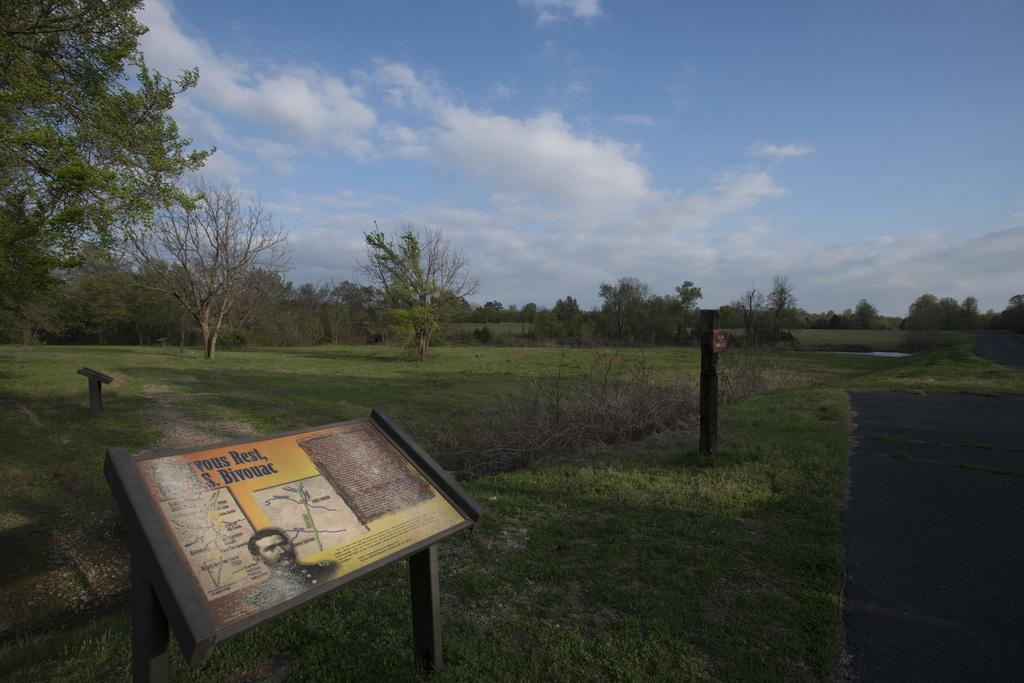What is the main object in the image? There is a board in the image. What is featured on the board? A person is depicted on the board, and there is text on the board. Where is the board located? The board is located to the side of the road. What can be seen in the background of the image? There are trees, clouds, and a blue sky visible in the background of the image. How many weeks does the person on the board suggest to wait before taking action? The image does not provide any information about the person's suggestions or the number of weeks, as it only shows a person depicted on the board with text. 